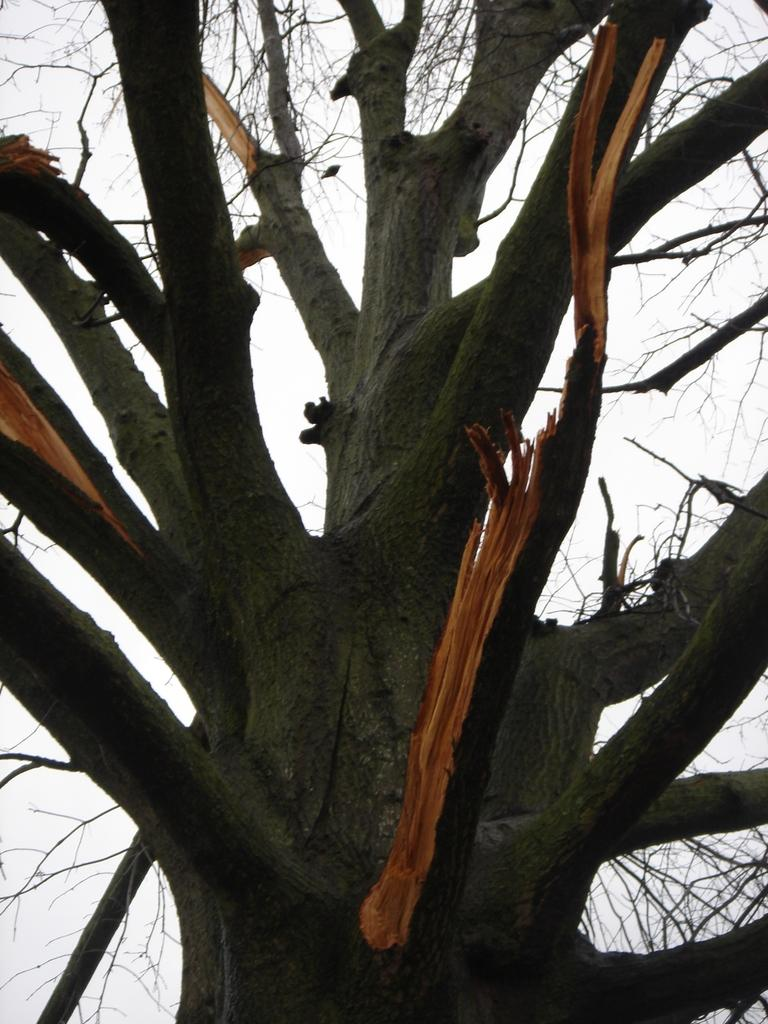What is the main subject of the picture? The main subject of the picture is a tree trunk. What features can be observed on the tree trunk? The tree trunk has branches. What can be seen in the background of the picture? The sky is visible in the background of the picture. What type of baseball example can be seen in the picture? There is no baseball or example present in the picture; it features a tree trunk with branches. How is the waste being managed in the picture? There is no waste management depicted in the picture, as it focuses on a tree trunk and the sky. 